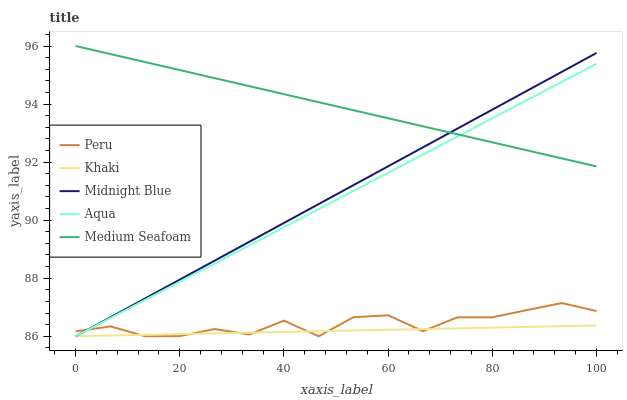Does Aqua have the minimum area under the curve?
Answer yes or no. No. Does Aqua have the maximum area under the curve?
Answer yes or no. No. Is Aqua the smoothest?
Answer yes or no. No. Is Aqua the roughest?
Answer yes or no. No. Does Medium Seafoam have the lowest value?
Answer yes or no. No. Does Aqua have the highest value?
Answer yes or no. No. Is Peru less than Medium Seafoam?
Answer yes or no. Yes. Is Medium Seafoam greater than Peru?
Answer yes or no. Yes. Does Peru intersect Medium Seafoam?
Answer yes or no. No. 